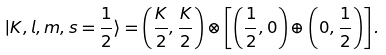<formula> <loc_0><loc_0><loc_500><loc_500>| K , l , m , s = \frac { 1 } { 2 } \rangle = \left ( \frac { K } { 2 } , \frac { K } { 2 } \right ) \otimes \left [ \left ( \frac { 1 } { 2 } , 0 \right ) \oplus \left ( 0 , \frac { 1 } { 2 } \right ) \right ] .</formula> 